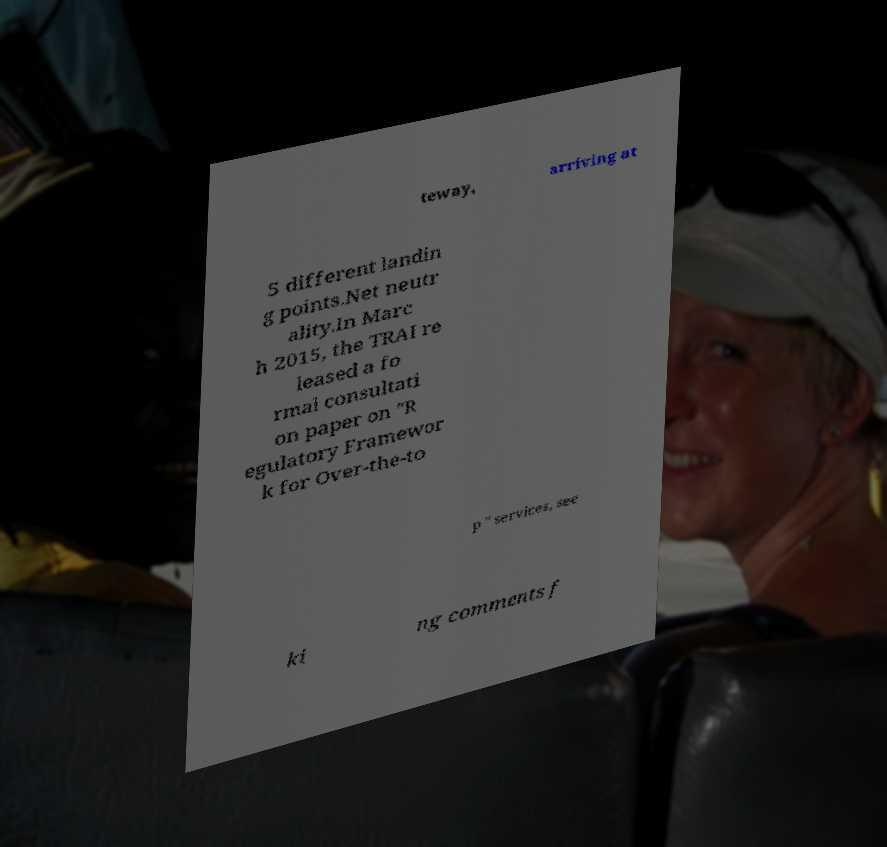Could you extract and type out the text from this image? teway, arriving at 5 different landin g points.Net neutr ality.In Marc h 2015, the TRAI re leased a fo rmal consultati on paper on "R egulatory Framewor k for Over-the-to p " services, see ki ng comments f 